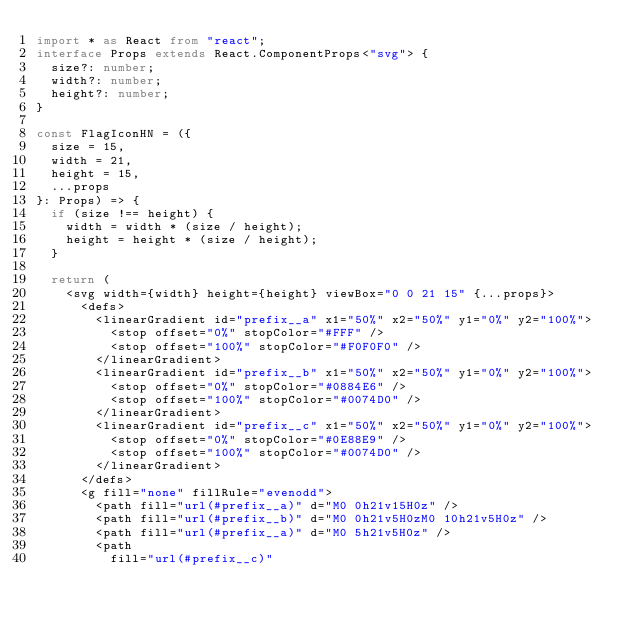<code> <loc_0><loc_0><loc_500><loc_500><_TypeScript_>import * as React from "react";
interface Props extends React.ComponentProps<"svg"> {
  size?: number;
  width?: number;
  height?: number;
}

const FlagIconHN = ({
  size = 15,
  width = 21,
  height = 15,
  ...props
}: Props) => {
  if (size !== height) {
    width = width * (size / height);
    height = height * (size / height);
  }

  return (
    <svg width={width} height={height} viewBox="0 0 21 15" {...props}>
      <defs>
        <linearGradient id="prefix__a" x1="50%" x2="50%" y1="0%" y2="100%">
          <stop offset="0%" stopColor="#FFF" />
          <stop offset="100%" stopColor="#F0F0F0" />
        </linearGradient>
        <linearGradient id="prefix__b" x1="50%" x2="50%" y1="0%" y2="100%">
          <stop offset="0%" stopColor="#0884E6" />
          <stop offset="100%" stopColor="#0074D0" />
        </linearGradient>
        <linearGradient id="prefix__c" x1="50%" x2="50%" y1="0%" y2="100%">
          <stop offset="0%" stopColor="#0E88E9" />
          <stop offset="100%" stopColor="#0074D0" />
        </linearGradient>
      </defs>
      <g fill="none" fillRule="evenodd">
        <path fill="url(#prefix__a)" d="M0 0h21v15H0z" />
        <path fill="url(#prefix__b)" d="M0 0h21v5H0zM0 10h21v5H0z" />
        <path fill="url(#prefix__a)" d="M0 5h21v5H0z" />
        <path
          fill="url(#prefix__c)"</code> 